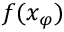Convert formula to latex. <formula><loc_0><loc_0><loc_500><loc_500>f ( x _ { \varphi } )</formula> 